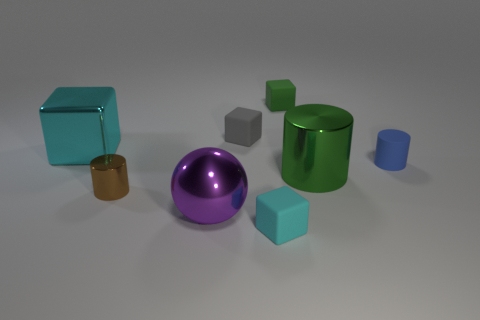Subtract all yellow spheres. How many cyan blocks are left? 2 Subtract all green matte cubes. How many cubes are left? 3 Subtract all gray blocks. How many blocks are left? 3 Add 1 red shiny balls. How many objects exist? 9 Subtract all cyan cylinders. Subtract all purple blocks. How many cylinders are left? 3 Subtract all cylinders. How many objects are left? 5 Add 5 spheres. How many spheres exist? 6 Subtract 0 red balls. How many objects are left? 8 Subtract all gray cubes. Subtract all big purple shiny cylinders. How many objects are left? 7 Add 7 tiny cyan rubber things. How many tiny cyan rubber things are left? 8 